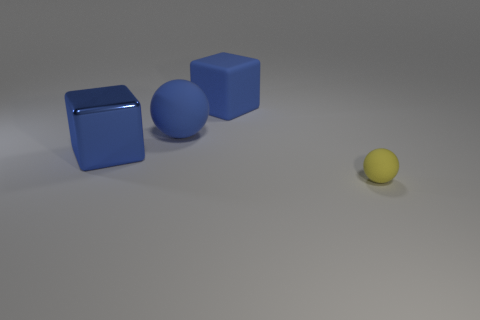Are there any other things that have the same size as the blue shiny block?
Provide a succinct answer. Yes. What number of big rubber things have the same color as the metal cube?
Provide a succinct answer. 2. There is a matte cube; are there any blue rubber things on the left side of it?
Provide a short and direct response. Yes. There is a yellow object; is it the same shape as the large object on the left side of the big ball?
Your answer should be very brief. No. What number of objects are balls in front of the big blue metal object or large blue rubber things?
Your answer should be very brief. 3. Are there any other things that have the same material as the small yellow ball?
Provide a short and direct response. Yes. How many matte things are both in front of the big matte ball and behind the tiny rubber thing?
Your response must be concise. 0. What number of things are matte objects that are behind the small yellow thing or big blue shiny blocks that are to the left of the tiny rubber thing?
Your answer should be very brief. 3. What number of other things are there of the same shape as the yellow thing?
Ensure brevity in your answer.  1. There is a sphere behind the yellow sphere; is it the same color as the large metal object?
Give a very brief answer. Yes. 